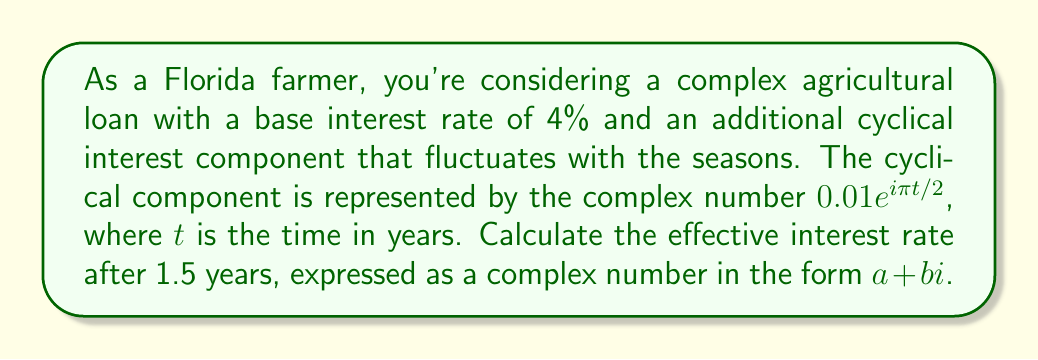Could you help me with this problem? To solve this problem, we'll follow these steps:

1) The complex interest rate is given by the sum of the base rate and the cyclical component:

   $r(t) = 0.04 + 0.01e^{i\pi t/2}$

2) We need to evaluate this at $t = 1.5$ years:

   $r(1.5) = 0.04 + 0.01e^{i\pi (1.5)/2}$

3) Let's simplify the exponent:

   $e^{i\pi (1.5)/2} = e^{i\pi 0.75} = e^{i(3\pi/4)}$

4) Recall Euler's formula: $e^{ix} = \cos x + i \sin x$

   So, $e^{i(3\pi/4)} = \cos(3\pi/4) + i \sin(3\pi/4)$

5) Calculate these trigonometric values:

   $\cos(3\pi/4) = -\frac{\sqrt{2}}{2}$
   $\sin(3\pi/4) = \frac{\sqrt{2}}{2}$

6) Substituting back:

   $r(1.5) = 0.04 + 0.01(-\frac{\sqrt{2}}{2} + i\frac{\sqrt{2}}{2})$

7) Simplify:

   $r(1.5) = 0.04 - 0.01\frac{\sqrt{2}}{2} + i(0.01\frac{\sqrt{2}}{2})$

8) Combine real and imaginary parts:

   $r(1.5) = (0.04 - 0.01\frac{\sqrt{2}}{2}) + i(0.01\frac{\sqrt{2}}{2})$
Answer: $r(1.5) = (0.04 - 0.01\frac{\sqrt{2}}{2}) + i(0.01\frac{\sqrt{2}}{2}) \approx 0.033 + 0.007i$ 